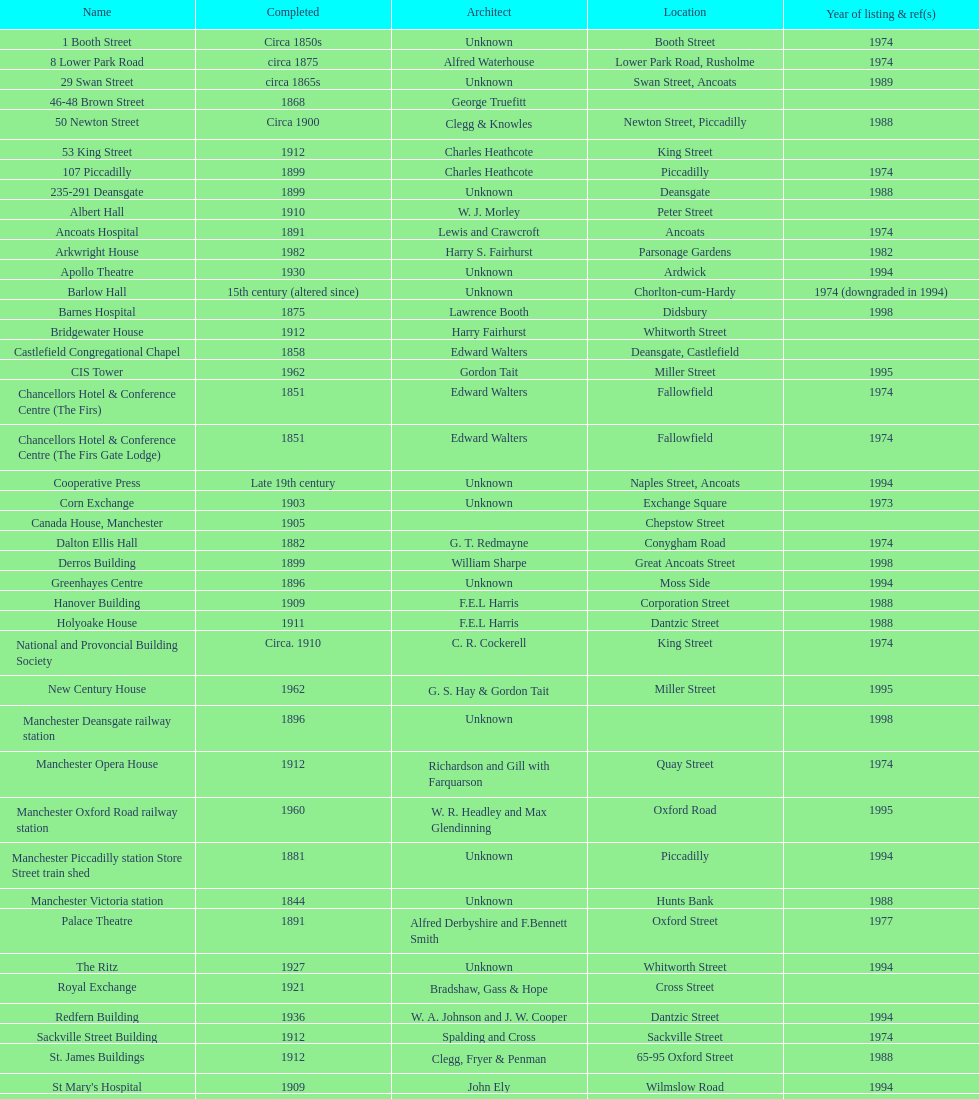What is the avenue of the unique building listed in 1989? Swan Street. 